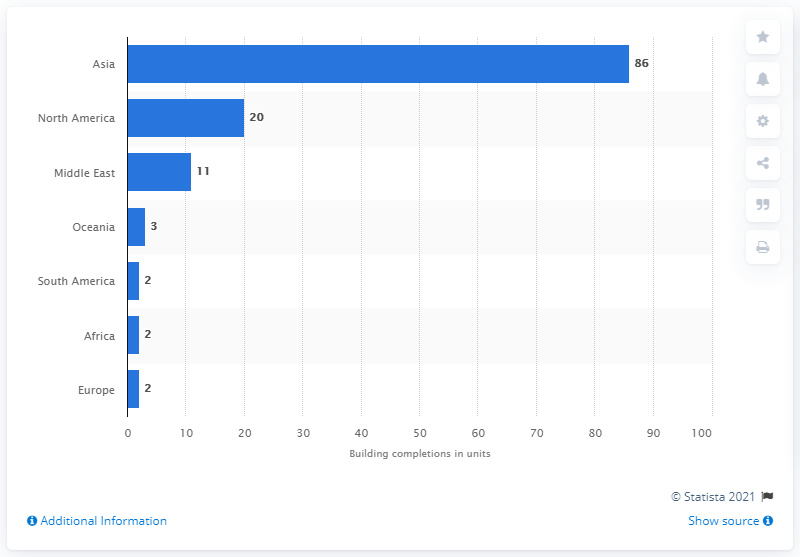Specify some key components in this picture. In 2019, a total of 86 tall buildings were completed in Asia. 